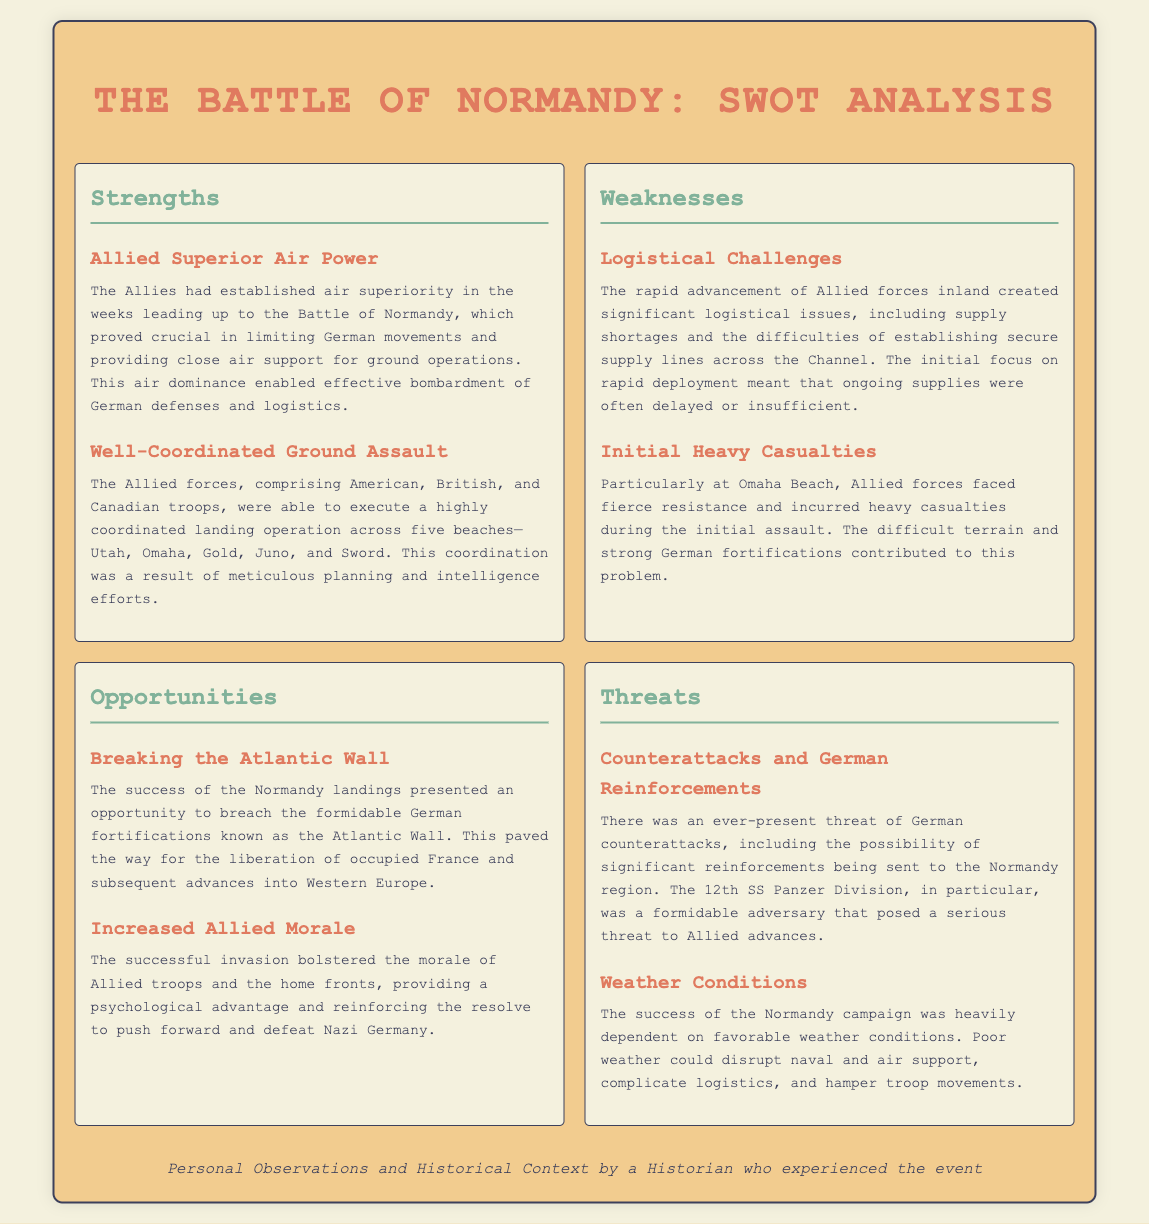what was a major strength of the Allies? One of the major strengths was the Allies' established air superiority prior to the battle, crucial in limiting German movements.
Answer: Allied Superior Air Power what beach incurred heavy casualties during the initial assault? The document specifies that Omaha Beach faced fierce resistance and heavy casualties during the initial assault.
Answer: Omaha Beach what logistical challenge was faced by the Allies? The document notes significant logistical issues due to rapid advances of Allied forces inland, affecting supply lines.
Answer: Logistical Challenges what opportunity did the success at Normandy present? The success of the Normandy landings provided an opportunity to breach the German fortifications known as the Atlantic Wall.
Answer: Breaking the Atlantic Wall which division posed a serious threat to Allied advances? The document mentions the 12th SS Panzer Division as a formidable adversary threatening Allied advances in Normandy.
Answer: 12th SS Panzer Division how did the Normandy invasion impact Allied morale? The successful invasion bolstered the morale of troops and home fronts, providing a psychological advantage.
Answer: Increased Allied Morale what was a significant weakness in terms of supply? The document discusses the effects of supply shortages and difficulties in establishing secure supply lines.
Answer: Supply shortages how did weather conditions affect the campaign? The success of the Normandy campaign depended on favorable weather, which could disrupt operations if poor.
Answer: Weather Conditions 